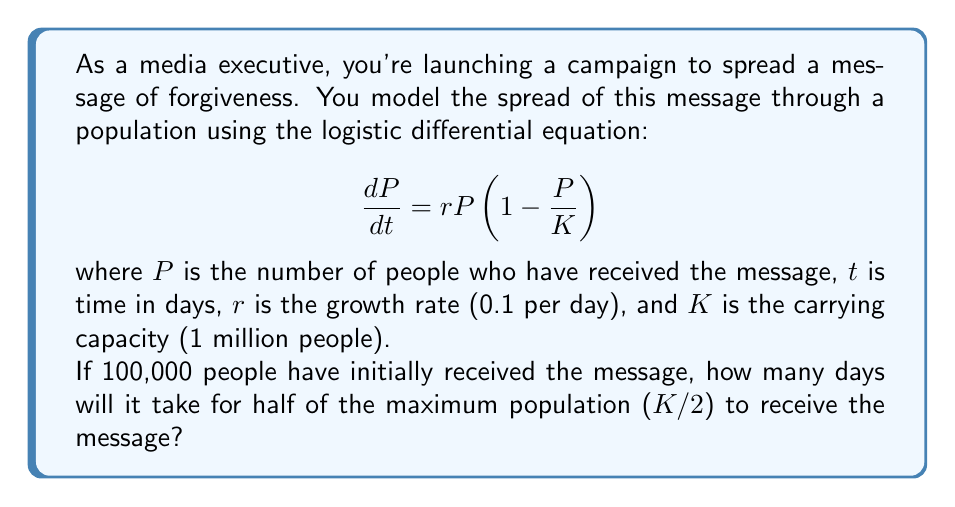Help me with this question. To solve this problem, we need to use the analytical solution of the logistic differential equation:

$$P(t) = \frac{K}{1 + (\frac{K}{P_0} - 1)e^{-rt}}$$

Where $P_0$ is the initial population that received the message.

Given:
$K = 1,000,000$
$r = 0.1$
$P_0 = 100,000$

We want to find $t$ when $P(t) = K/2 = 500,000$

Step 1: Substitute the values into the equation:

$$500,000 = \frac{1,000,000}{1 + (\frac{1,000,000}{100,000} - 1)e^{-0.1t}}$$

Step 2: Simplify:

$$0.5 = \frac{1}{1 + 9e^{-0.1t}}$$

Step 3: Solve for $t$:

$$1 + 9e^{-0.1t} = 2$$
$$9e^{-0.1t} = 1$$
$$e^{-0.1t} = \frac{1}{9}$$
$$-0.1t = \ln(\frac{1}{9})$$
$$t = -10 \ln(\frac{1}{9})$$
$$t = 10 \ln(9)$$

Step 4: Calculate the final result:

$$t \approx 21.97 \text{ days}$$
Answer: It will take approximately 22 days for half of the maximum population to receive the message of forgiveness. 